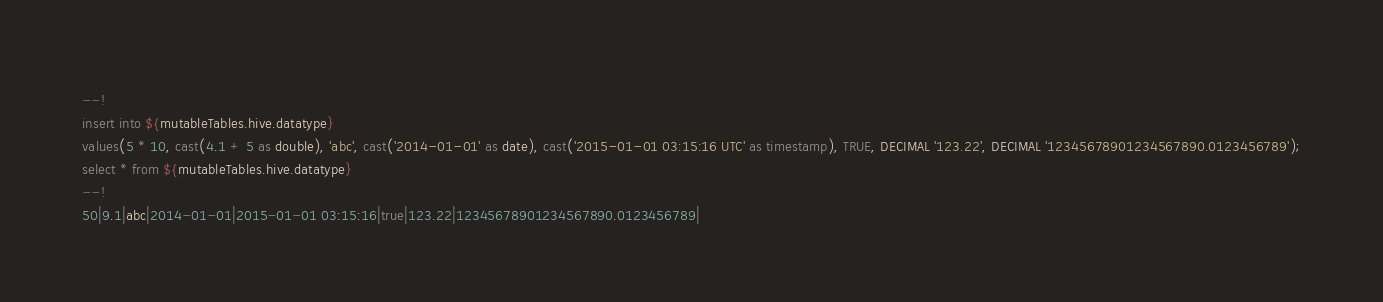<code> <loc_0><loc_0><loc_500><loc_500><_SQL_>--!
insert into ${mutableTables.hive.datatype}
values(5 * 10, cast(4.1 + 5 as double), 'abc', cast('2014-01-01' as date), cast('2015-01-01 03:15:16 UTC' as timestamp), TRUE, DECIMAL '123.22', DECIMAL '12345678901234567890.0123456789');
select * from ${mutableTables.hive.datatype}
--!
50|9.1|abc|2014-01-01|2015-01-01 03:15:16|true|123.22|12345678901234567890.0123456789|
</code> 